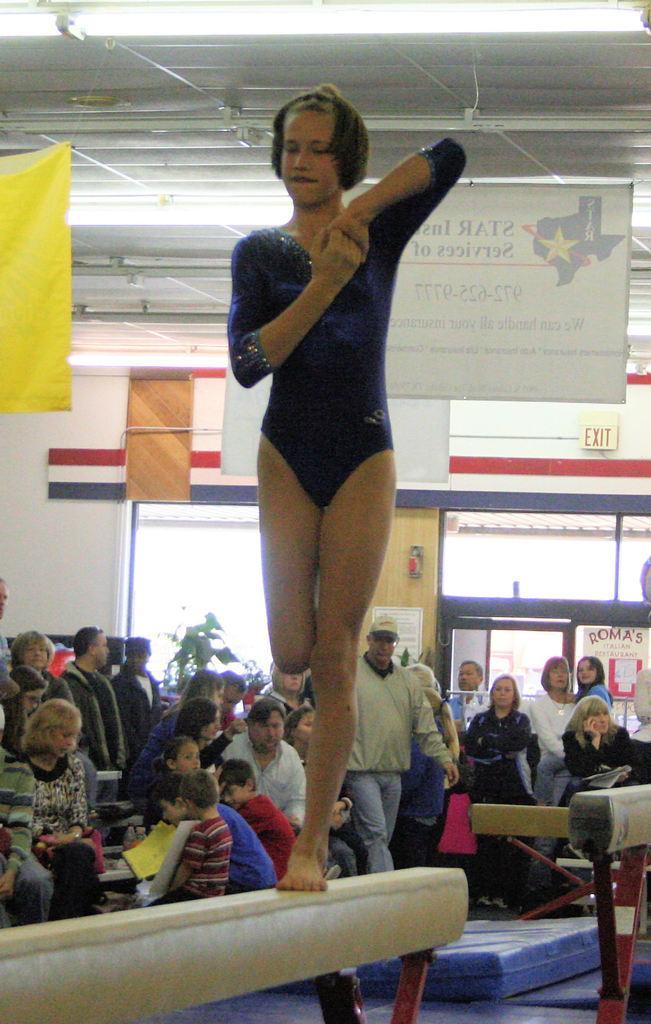How would you summarize this image in a sentence or two? In this image I can see a woman wearing black color dress is standing on the cream colored pole. In the background I can see few persons sitting, few persons standing, the wall, the ceiling, few lights to the ceiling, a blue colored bed and few other objects. I can see the glass window and a plant. 